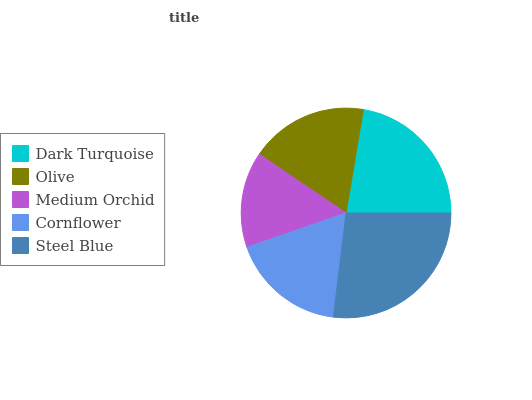Is Medium Orchid the minimum?
Answer yes or no. Yes. Is Steel Blue the maximum?
Answer yes or no. Yes. Is Olive the minimum?
Answer yes or no. No. Is Olive the maximum?
Answer yes or no. No. Is Dark Turquoise greater than Olive?
Answer yes or no. Yes. Is Olive less than Dark Turquoise?
Answer yes or no. Yes. Is Olive greater than Dark Turquoise?
Answer yes or no. No. Is Dark Turquoise less than Olive?
Answer yes or no. No. Is Olive the high median?
Answer yes or no. Yes. Is Olive the low median?
Answer yes or no. Yes. Is Cornflower the high median?
Answer yes or no. No. Is Steel Blue the low median?
Answer yes or no. No. 